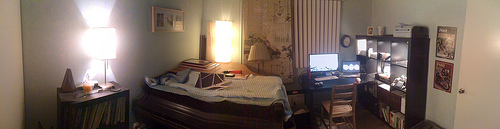Please provide the bounding box coordinate of the region this sentence describes: the back chair legs. The coordinates might be slightly off for the chair's back legs. A more accurate bounding box could be [0.65, 0.61, 0.69, 0.63], which would capture just the legs without interference from the surrounding area. 